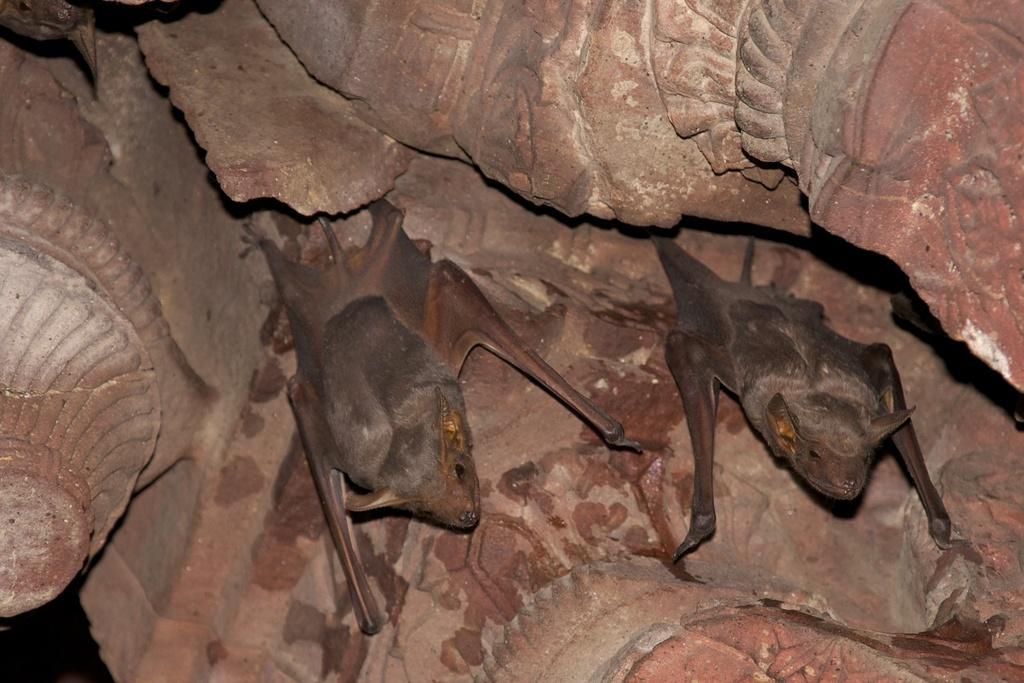Please provide a concise description of this image. In the foreground of this picture, there are two bats on a stone wall. 